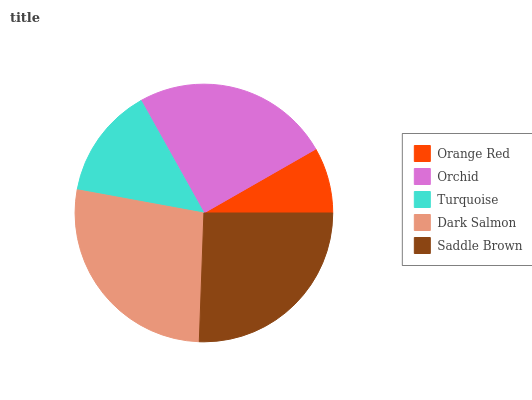Is Orange Red the minimum?
Answer yes or no. Yes. Is Dark Salmon the maximum?
Answer yes or no. Yes. Is Orchid the minimum?
Answer yes or no. No. Is Orchid the maximum?
Answer yes or no. No. Is Orchid greater than Orange Red?
Answer yes or no. Yes. Is Orange Red less than Orchid?
Answer yes or no. Yes. Is Orange Red greater than Orchid?
Answer yes or no. No. Is Orchid less than Orange Red?
Answer yes or no. No. Is Orchid the high median?
Answer yes or no. Yes. Is Orchid the low median?
Answer yes or no. Yes. Is Saddle Brown the high median?
Answer yes or no. No. Is Turquoise the low median?
Answer yes or no. No. 